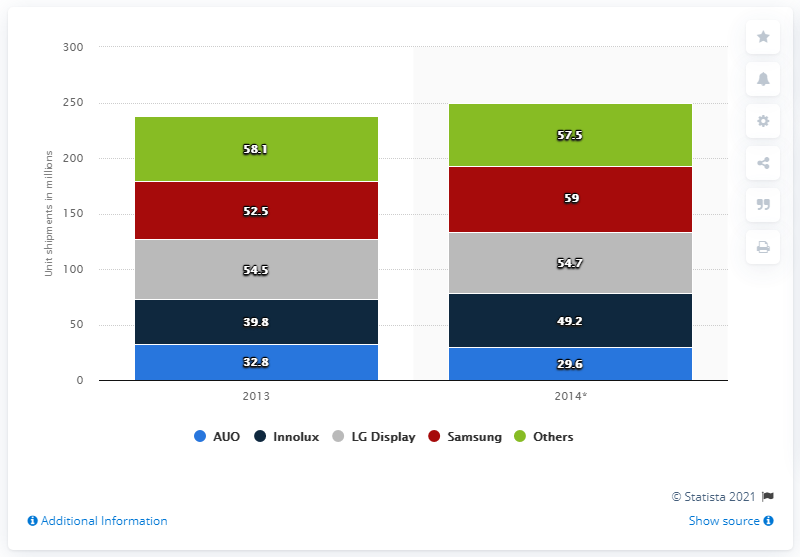Indicate a few pertinent items in this graphic. In 2013, LG Display shipped a total of 54,700 LCD TV panels. 